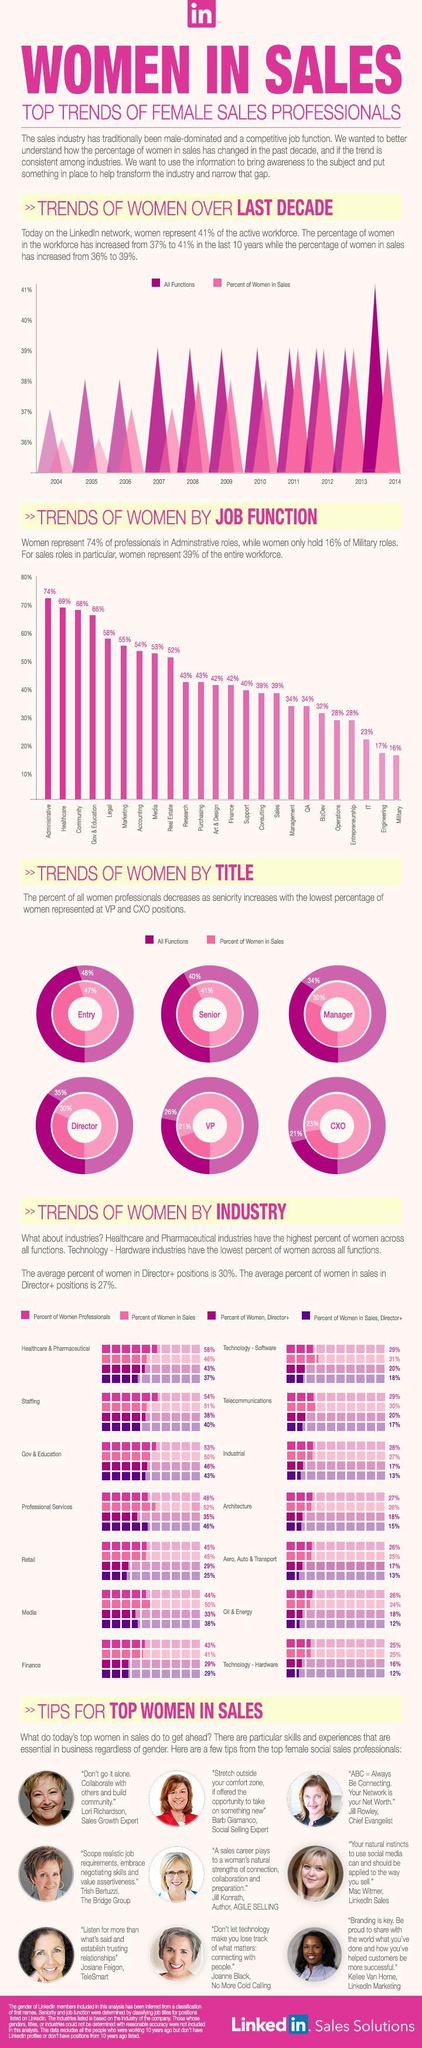What is the percentage of women sales professionals in Oil & Energy?
Answer the question with a short phrase. 24% What is percentage of women in Art and design and finance? 42% What is the total percentage of women in VP and CXO roles? 44% What was the percentage women in sales during from 2011 -13? 39% For how many years the percentage of women in all functions did not increase from 39%? 7 What is the percentage of women professionals in Architecture? 27% What is the percentage of women Sales  Directors in Hardware? 12% What percentage of women managers in all functions? 34% What is the percentage of women Directors in Retail? 29% What job functions do 43% percentage of women get into? Research, Purchasing 